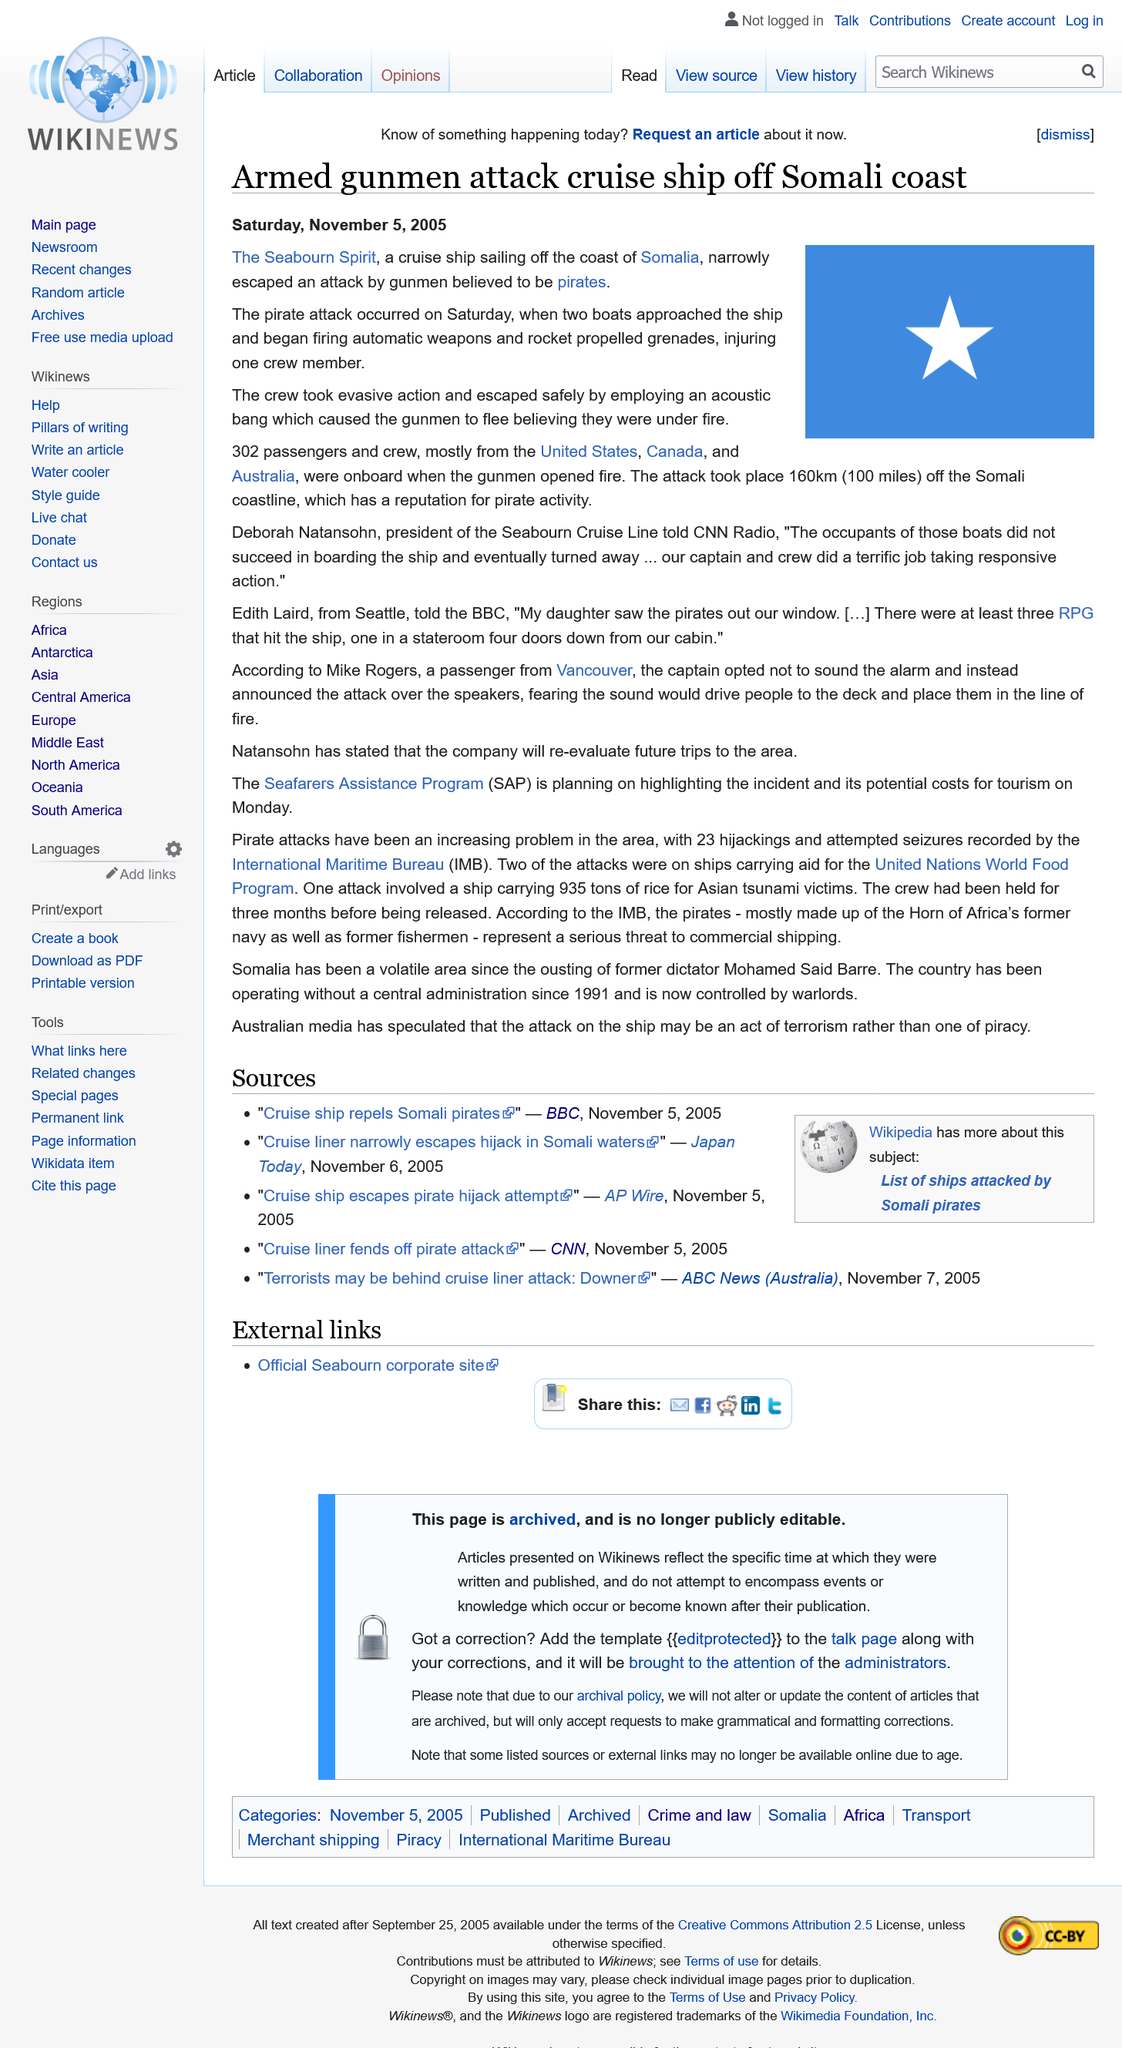Mention a couple of crucial points in this snapshot. The flag of Somalia, which is a horizontal tricolor of green, white, and blue, is pictured. The cruise ship attacked is named The Seabourn Spirit. On the day of the attack, there were 302 passengers and crew onboard the cruise ship. 